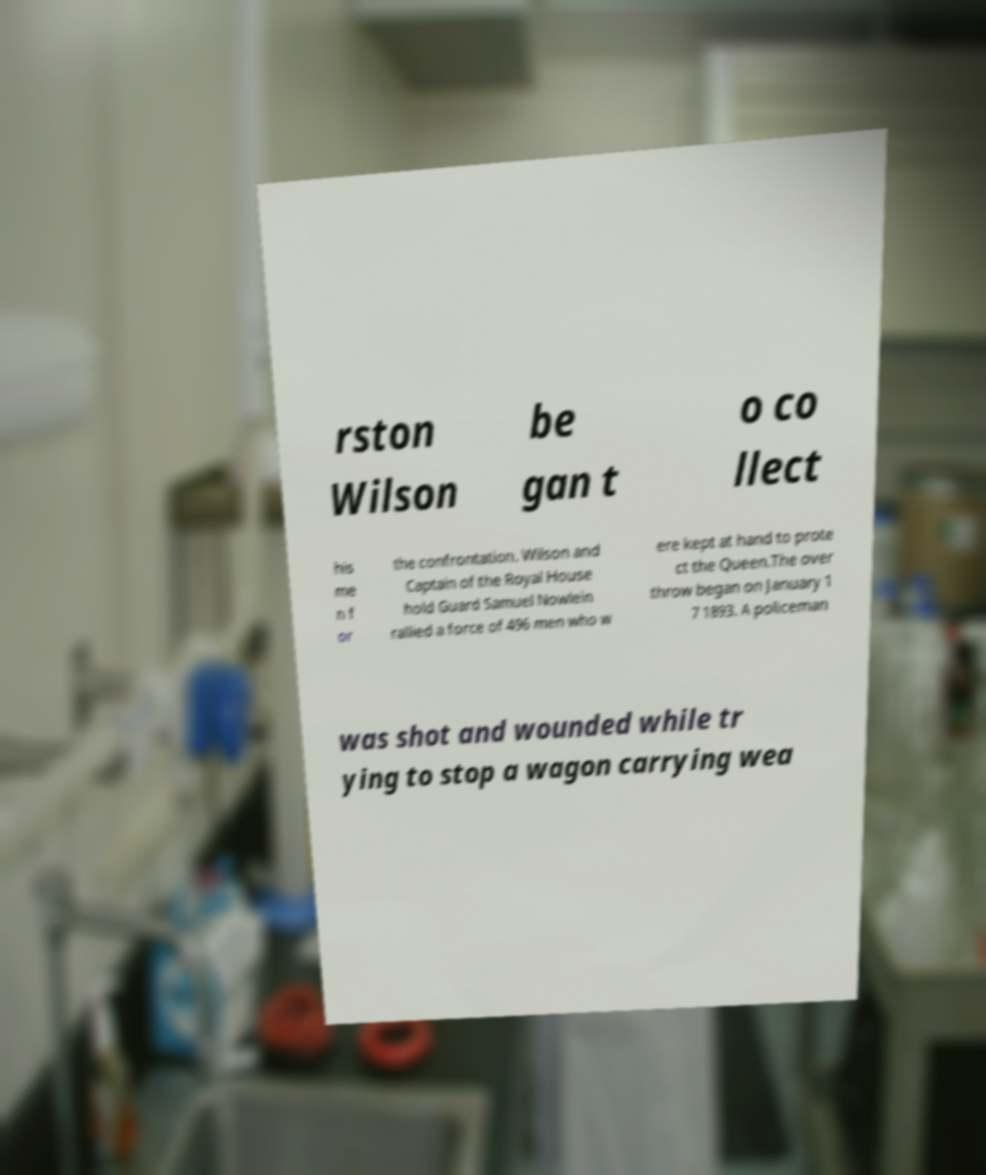Could you assist in decoding the text presented in this image and type it out clearly? rston Wilson be gan t o co llect his me n f or the confrontation. Wilson and Captain of the Royal House hold Guard Samuel Nowlein rallied a force of 496 men who w ere kept at hand to prote ct the Queen.The over throw began on January 1 7 1893. A policeman was shot and wounded while tr ying to stop a wagon carrying wea 